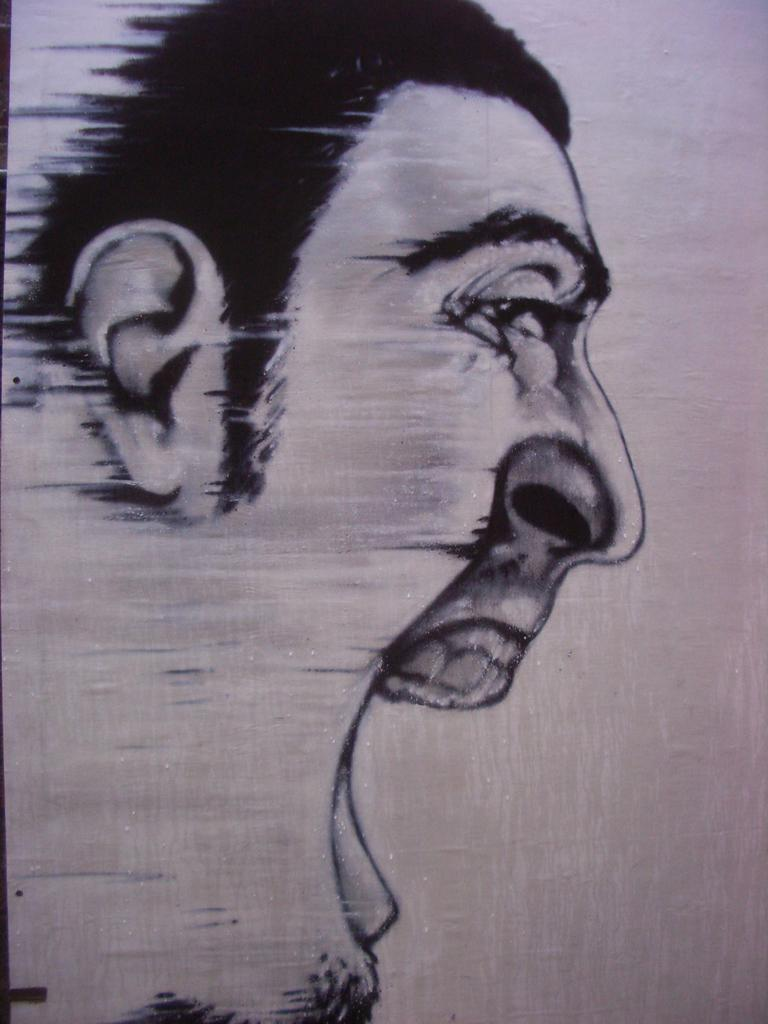What is depicted on the paper in the image? There is a sketch drawn on a paper in the image. What type of sound can be heard coming from the sketch in the image? There is no sound coming from the sketch in the image, as it is a static drawing on paper. 